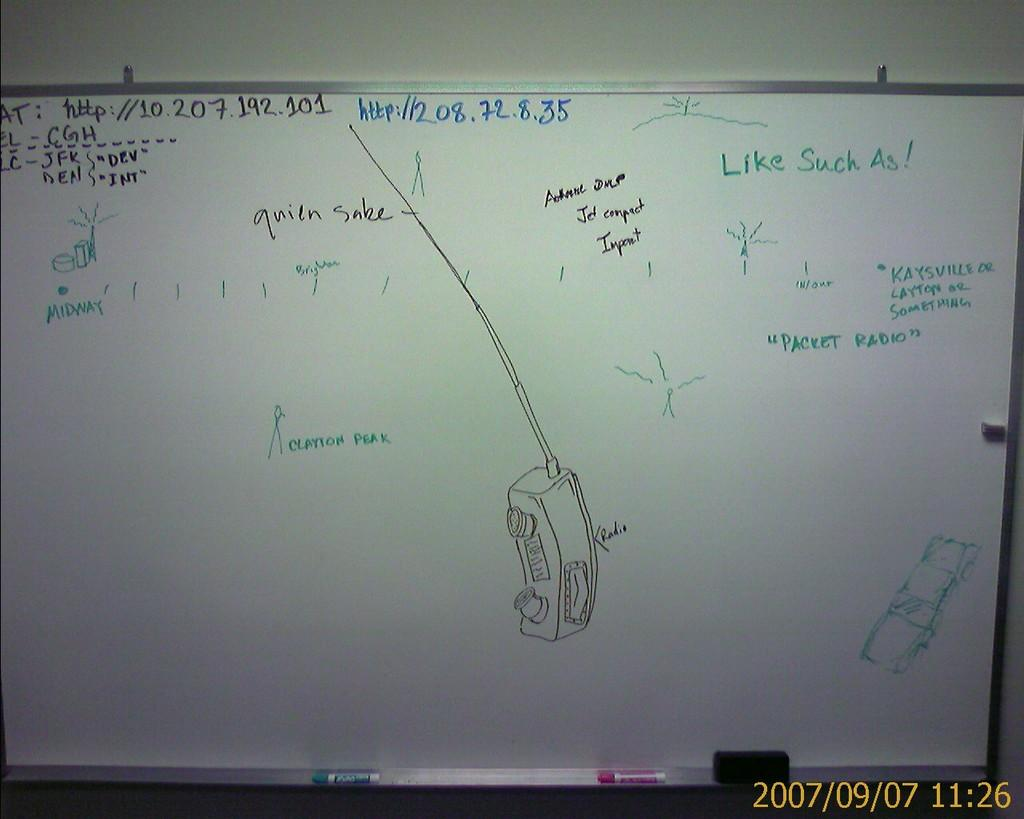<image>
Offer a succinct explanation of the picture presented. A whiteboard with a web address of 10.207.192.101 written on it. 